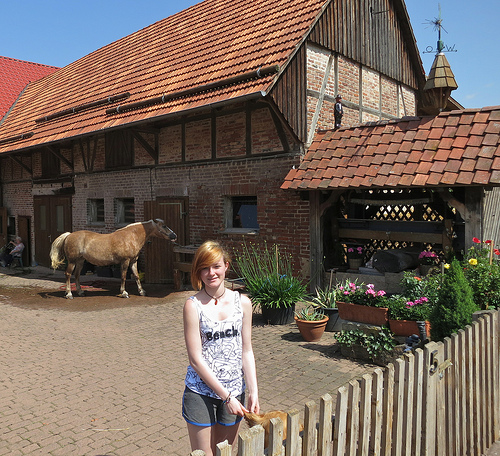<image>
Is there a horse behind the woman? Yes. From this viewpoint, the horse is positioned behind the woman, with the woman partially or fully occluding the horse. 